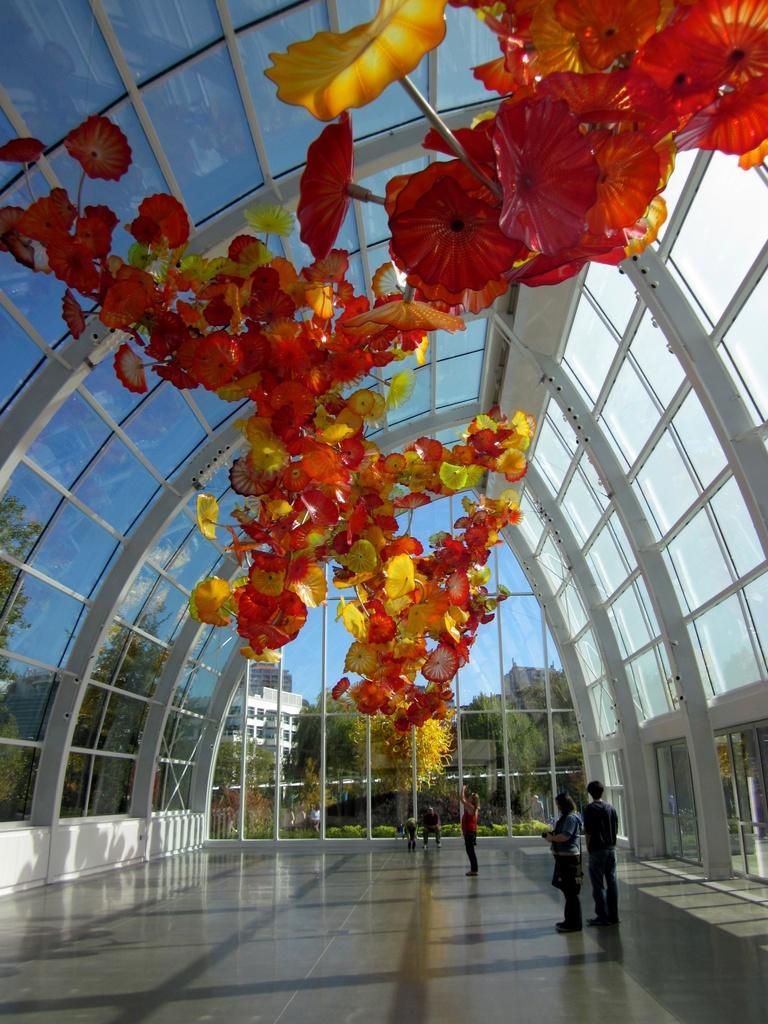How would you summarize this image in a sentence or two? In this image we can see flowers, trees, persons, glass windows, doors, trees, buildings and sky. 